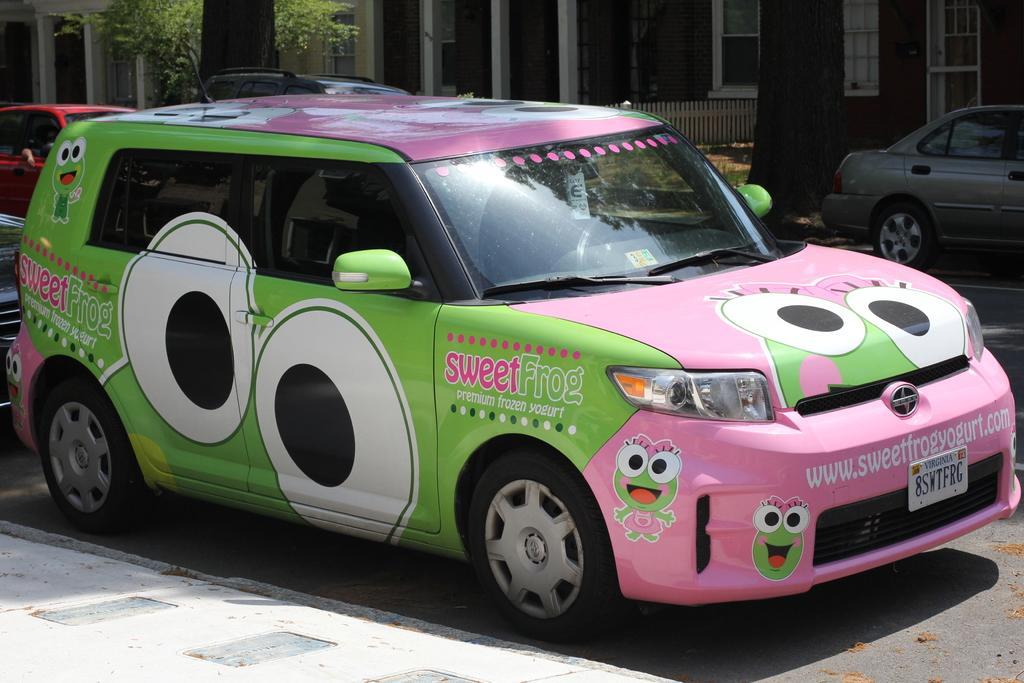Can you describe this image briefly? In this image in front there are cars on the road. In the background of the image there is a metal fence. There is a tree and there are buildings. 